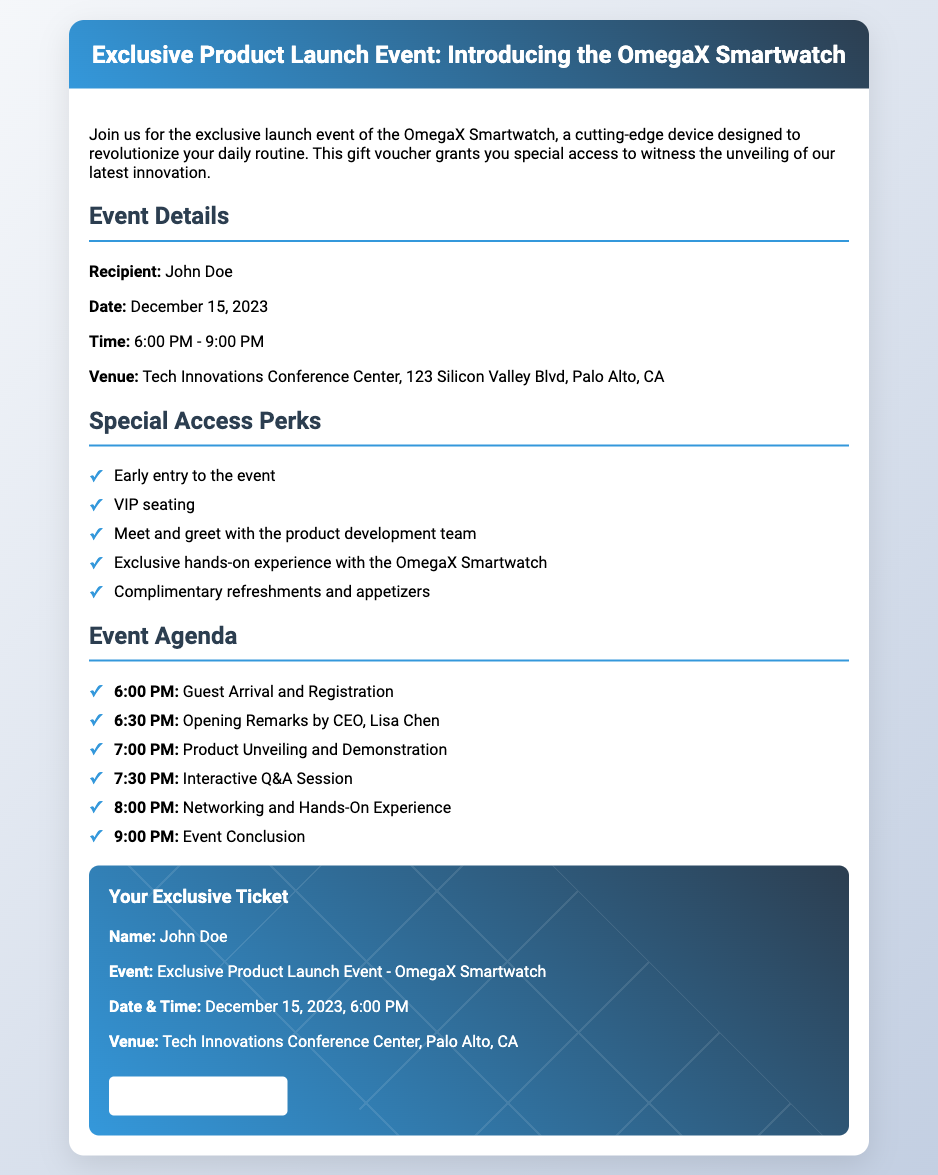What is the recipient's name? The recipient's name is explicitly stated in the details section of the document.
Answer: John Doe What is the date of the event? The event date is provided in the event details section of the document.
Answer: December 15, 2023 What time does the event start? The starting time of the event is mentioned in the event details.
Answer: 6:00 PM How many special access perks are listed? The number of special access perks can be counted from the perks section of the document.
Answer: Five What is one of the agenda items listed for 6:30 PM? The agenda item for that time is included in the event agenda section.
Answer: Opening Remarks by CEO, Lisa Chen What is the name of the product being launched? The product name is mentioned in the header of the document.
Answer: OmegaX Smartwatch What type of document is this? The characteristics of the document indicate it is a type of gift voucher.
Answer: Gift voucher What venue will the event take place in? The venue is specified in the event details section.
Answer: Tech Innovations Conference Center, Palo Alto, CA Which organization leader is speaking at the event? The speaker's name is mentioned in the agenda section.
Answer: Lisa Chen 